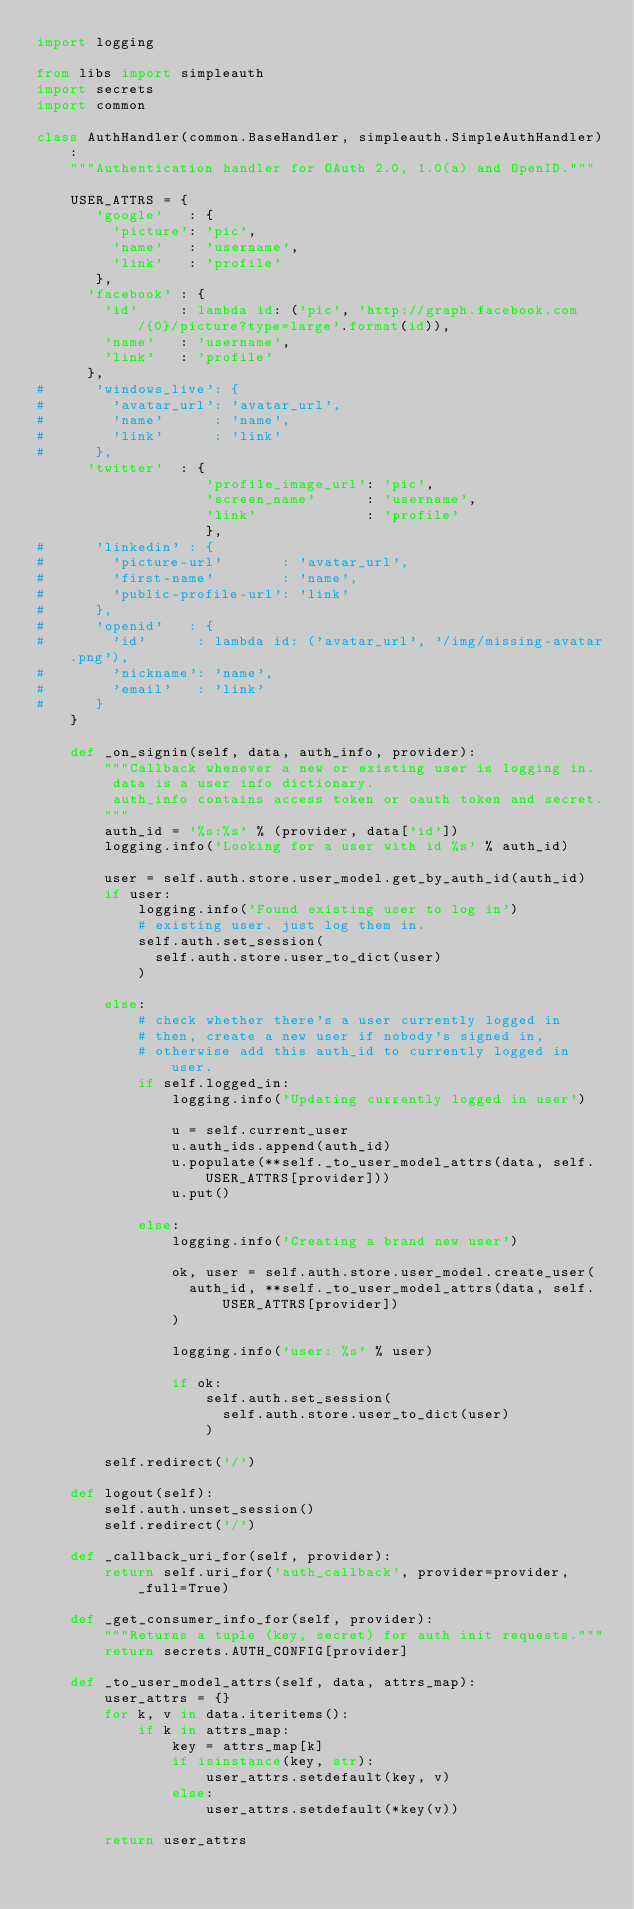<code> <loc_0><loc_0><loc_500><loc_500><_Python_>import logging

from libs import simpleauth
import secrets
import common

class AuthHandler(common.BaseHandler, simpleauth.SimpleAuthHandler):
    """Authentication handler for OAuth 2.0, 1.0(a) and OpenID."""

    USER_ATTRS = {
       'google'   : {
         'picture': 'pic',
         'name'   : 'username',
         'link'   : 'profile'
       },
      'facebook' : {
        'id'     : lambda id: ('pic', 'http://graph.facebook.com/{0}/picture?type=large'.format(id)),
        'name'   : 'username',
        'link'   : 'profile'
      },
#      'windows_live': {
#        'avatar_url': 'avatar_url',
#        'name'      : 'name',
#        'link'      : 'link'
#      },
      'twitter'  : {
                    'profile_image_url': 'pic',
                    'screen_name'      : 'username',
                    'link'             : 'profile'
                    },
#      'linkedin' : {
#        'picture-url'       : 'avatar_url',
#        'first-name'        : 'name',
#        'public-profile-url': 'link'
#      },
#      'openid'   : {
#        'id'      : lambda id: ('avatar_url', '/img/missing-avatar.png'),
#        'nickname': 'name',
#        'email'   : 'link'
#      }
    }

    def _on_signin(self, data, auth_info, provider):
        """Callback whenever a new or existing user is logging in.
         data is a user info dictionary.
         auth_info contains access token or oauth token and secret.
        """
        auth_id = '%s:%s' % (provider, data['id'])
        logging.info('Looking for a user with id %s' % auth_id)

        user = self.auth.store.user_model.get_by_auth_id(auth_id)
        if user:
            logging.info('Found existing user to log in')
            # existing user. just log them in.
            self.auth.set_session(
              self.auth.store.user_to_dict(user)
            )

        else:
            # check whether there's a user currently logged in
            # then, create a new user if nobody's signed in,
            # otherwise add this auth_id to currently logged in user.
            if self.logged_in:
                logging.info('Updating currently logged in user')

                u = self.current_user
                u.auth_ids.append(auth_id)
                u.populate(**self._to_user_model_attrs(data, self.USER_ATTRS[provider]))
                u.put()

            else:
                logging.info('Creating a brand new user')

                ok, user = self.auth.store.user_model.create_user(
                  auth_id, **self._to_user_model_attrs(data, self.USER_ATTRS[provider])
                )
                
                logging.info('user: %s' % user)
                
                if ok:
                    self.auth.set_session(
                      self.auth.store.user_to_dict(user)
                    )

        self.redirect('/')

    def logout(self):
        self.auth.unset_session()
        self.redirect('/')

    def _callback_uri_for(self, provider):
        return self.uri_for('auth_callback', provider=provider, _full=True)

    def _get_consumer_info_for(self, provider):
        """Returns a tuple (key, secret) for auth init requests."""
        return secrets.AUTH_CONFIG[provider]

    def _to_user_model_attrs(self, data, attrs_map):
        user_attrs = {}
        for k, v in data.iteritems():
            if k in attrs_map:
                key = attrs_map[k]
                if isinstance(key, str):
                    user_attrs.setdefault(key, v)
                else:
                    user_attrs.setdefault(*key(v))

        return user_attrs
</code> 